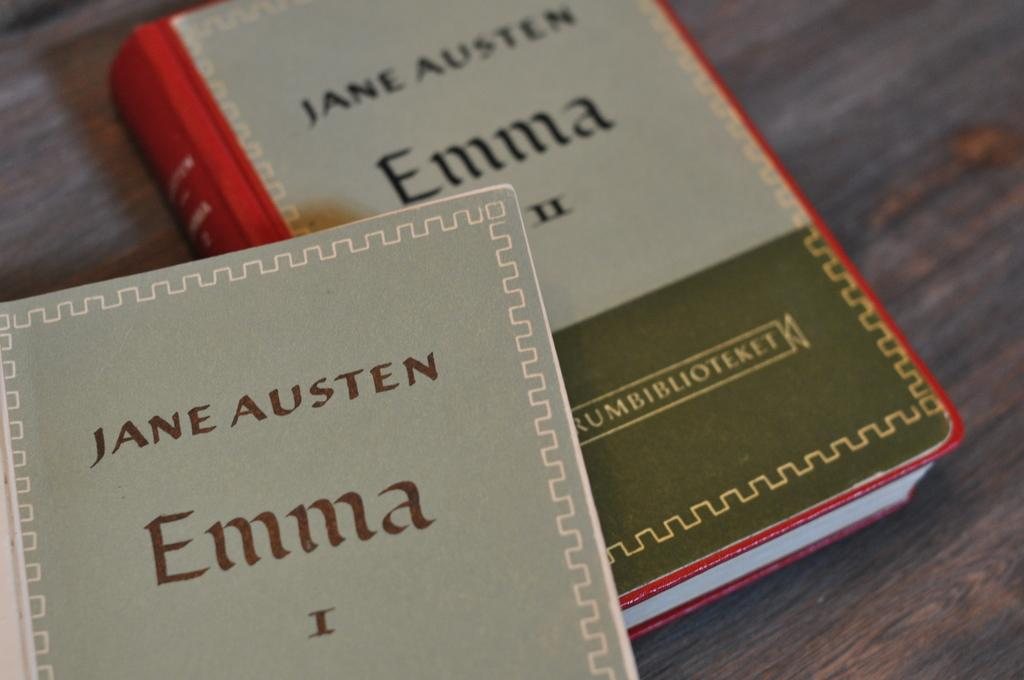<image>
Give a short and clear explanation of the subsequent image. The first and second Emma books by Jane Austen. 